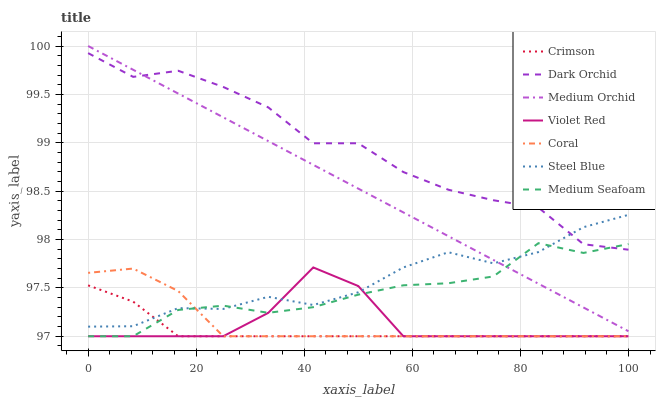Does Crimson have the minimum area under the curve?
Answer yes or no. Yes. Does Dark Orchid have the maximum area under the curve?
Answer yes or no. Yes. Does Coral have the minimum area under the curve?
Answer yes or no. No. Does Coral have the maximum area under the curve?
Answer yes or no. No. Is Medium Orchid the smoothest?
Answer yes or no. Yes. Is Dark Orchid the roughest?
Answer yes or no. Yes. Is Coral the smoothest?
Answer yes or no. No. Is Coral the roughest?
Answer yes or no. No. Does Medium Orchid have the lowest value?
Answer yes or no. No. Does Medium Orchid have the highest value?
Answer yes or no. Yes. Does Coral have the highest value?
Answer yes or no. No. Is Violet Red less than Medium Orchid?
Answer yes or no. Yes. Is Dark Orchid greater than Coral?
Answer yes or no. Yes. Does Violet Red intersect Coral?
Answer yes or no. Yes. Is Violet Red less than Coral?
Answer yes or no. No. Is Violet Red greater than Coral?
Answer yes or no. No. Does Violet Red intersect Medium Orchid?
Answer yes or no. No. 